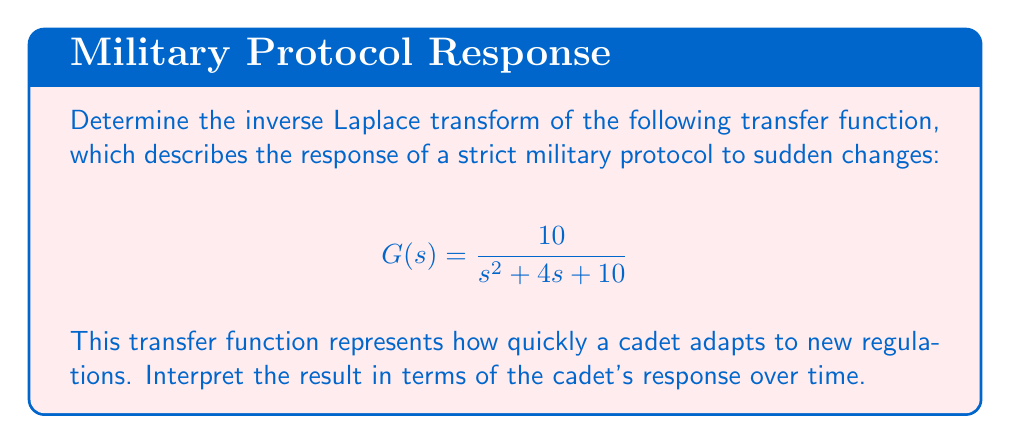What is the answer to this math problem? To find the inverse Laplace transform of the given transfer function, we'll follow these steps:

1) First, recognize that this transfer function is in the form of a second-order system:

   $$G(s) = \frac{\omega_n^2}{s^2 + 2\zeta\omega_n s + \omega_n^2}$$

   where $\omega_n$ is the natural frequency and $\zeta$ is the damping ratio.

2) Comparing our function to this standard form:

   $$\frac{10}{s^2 + 4s + 10} = \frac{\omega_n^2}{s^2 + 2\zeta\omega_n s + \omega_n^2}$$

   We can see that $\omega_n^2 = 10$, so $\omega_n = \sqrt{10}$.
   
   And $2\zeta\omega_n = 4$, so $\zeta = \frac{4}{2\sqrt{10}} = \frac{2}{\sqrt{10}}$.

3) The inverse Laplace transform of this system is:

   $$g(t) = 1 - e^{-\zeta\omega_n t} \left( \cos(\omega_d t) + \frac{\zeta}{\sqrt{1-\zeta^2}} \sin(\omega_d t) \right)$$

   where $\omega_d = \omega_n\sqrt{1-\zeta^2}$ is the damped natural frequency.

4) Calculate $\omega_d$:
   
   $$\omega_d = \sqrt{10}\sqrt{1-(\frac{2}{\sqrt{10}})^2} = \sqrt{10}\sqrt{\frac{6}{10}} = \sqrt{6}$$

5) Substituting all values:

   $$g(t) = 1 - e^{-2t} \left( \cos(\sqrt{6}t) + \frac{2/\sqrt{10}}{\sqrt{1-(2/\sqrt{10})^2}} \sin(\sqrt{6}t) \right)$$

   $$= 1 - e^{-2t} \left( \cos(\sqrt{6}t) + \frac{2}{\sqrt{6}} \sin(\sqrt{6}t) \right)$$

This function represents how the cadet's adherence to protocol changes over time. The exponential term $e^{-2t}$ shows a rapid initial adaptation, while the oscillating terms represent the cadet's tendency to overshoot and undershoot before settling into the new routine.
Answer: $$g(t) = 1 - e^{-2t} \left( \cos(\sqrt{6}t) + \frac{2}{\sqrt{6}} \sin(\sqrt{6}t) \right)$$ 